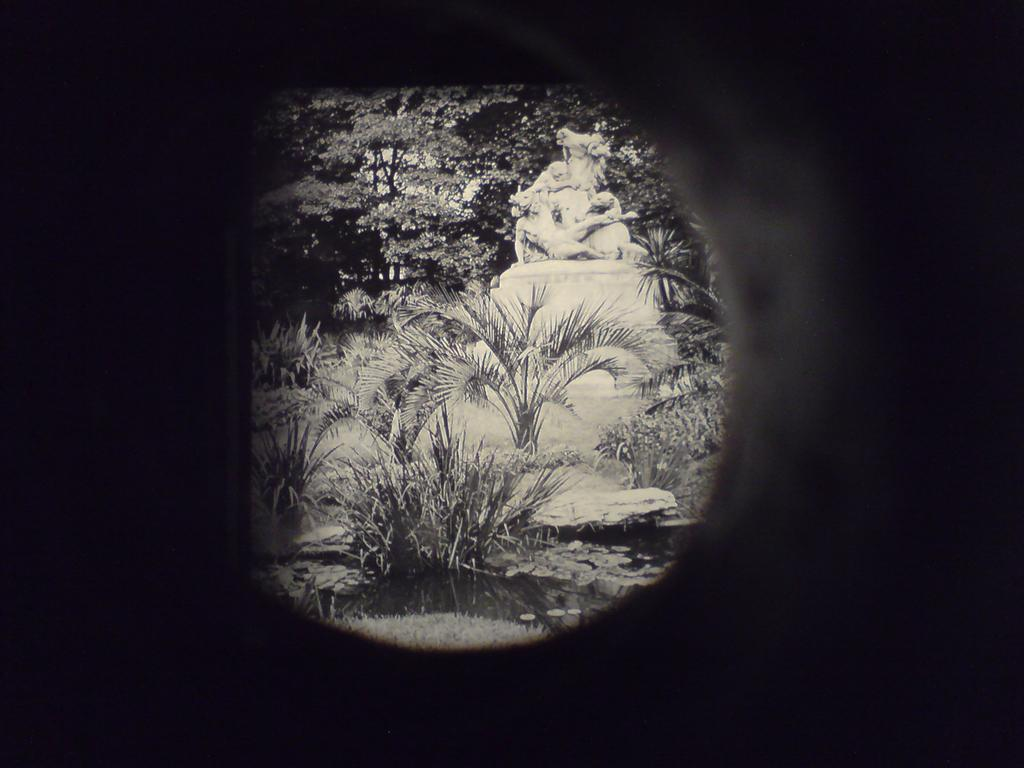Where was the image taken? The image is taken indoors. What can be seen in the middle of the image? There is a window in the middle of the image. What is visible through the window? Trees and plants are visible through the window. What type of artwork is present in the image? There is a sculpture in the image. Can you see a kitty playing with a flesh-colored ticket in the image? No, there is no kitty or ticket present in the image. 